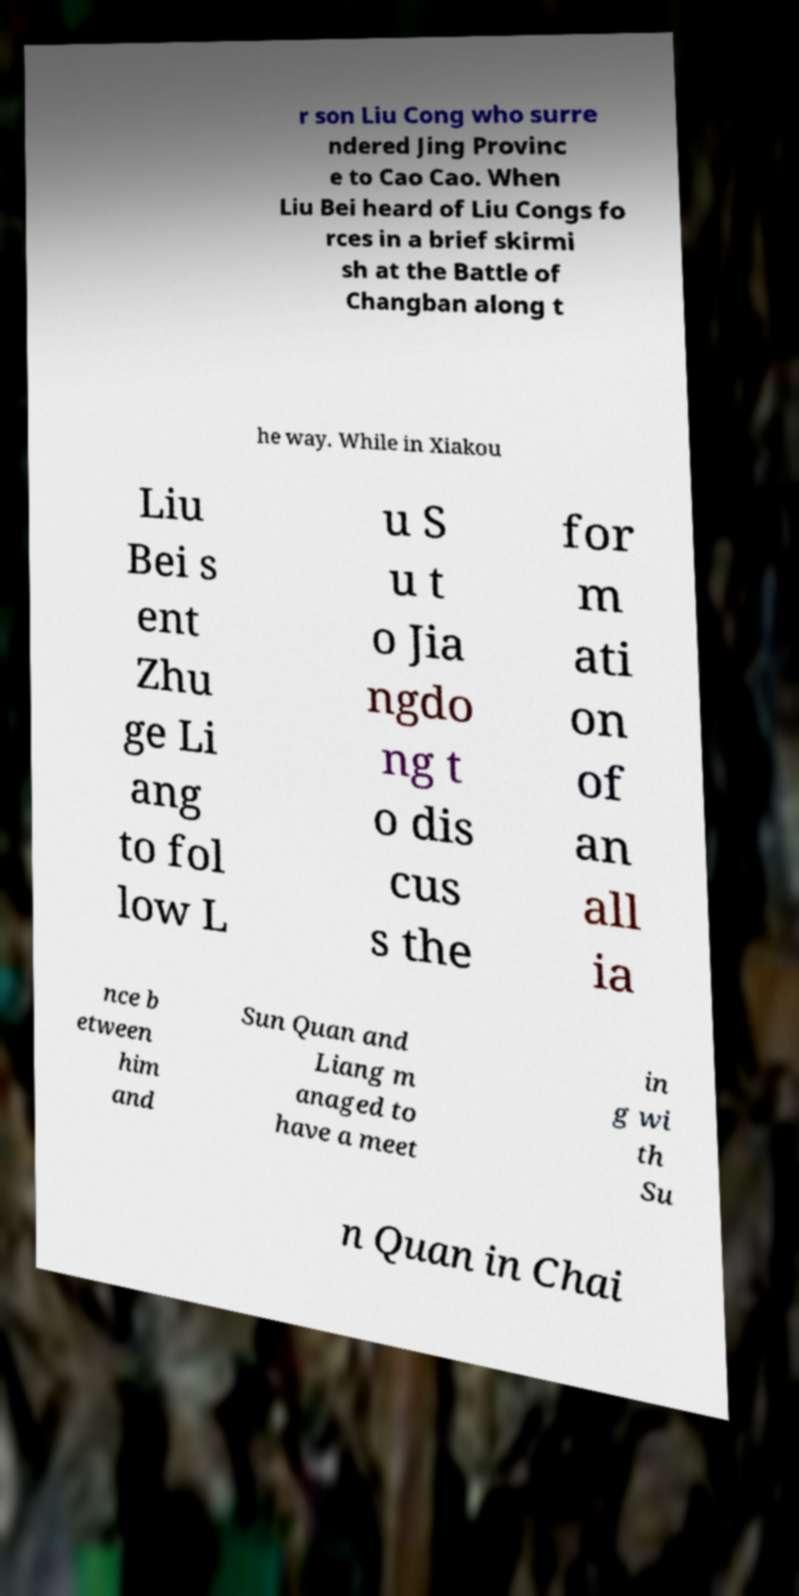I need the written content from this picture converted into text. Can you do that? r son Liu Cong who surre ndered Jing Provinc e to Cao Cao. When Liu Bei heard of Liu Congs fo rces in a brief skirmi sh at the Battle of Changban along t he way. While in Xiakou Liu Bei s ent Zhu ge Li ang to fol low L u S u t o Jia ngdo ng t o dis cus s the for m ati on of an all ia nce b etween him and Sun Quan and Liang m anaged to have a meet in g wi th Su n Quan in Chai 